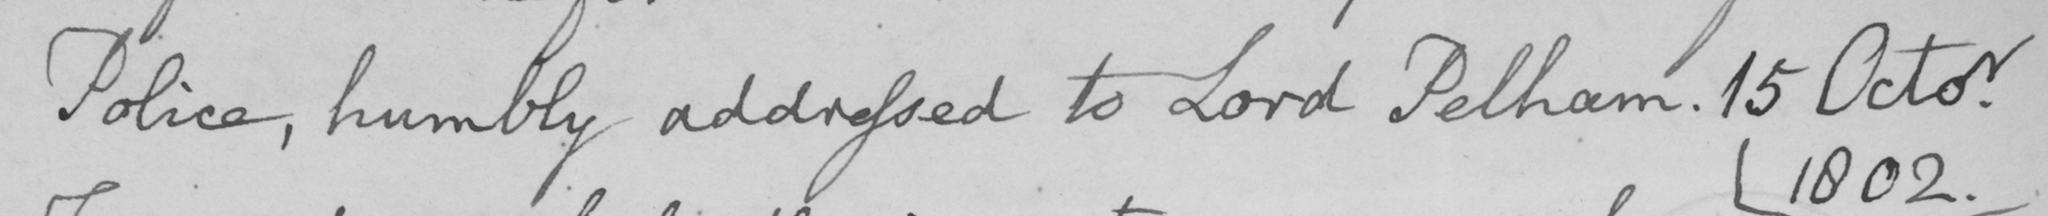What is written in this line of handwriting? Police , humbly addressed to Lord Pelham . 15 Octor 